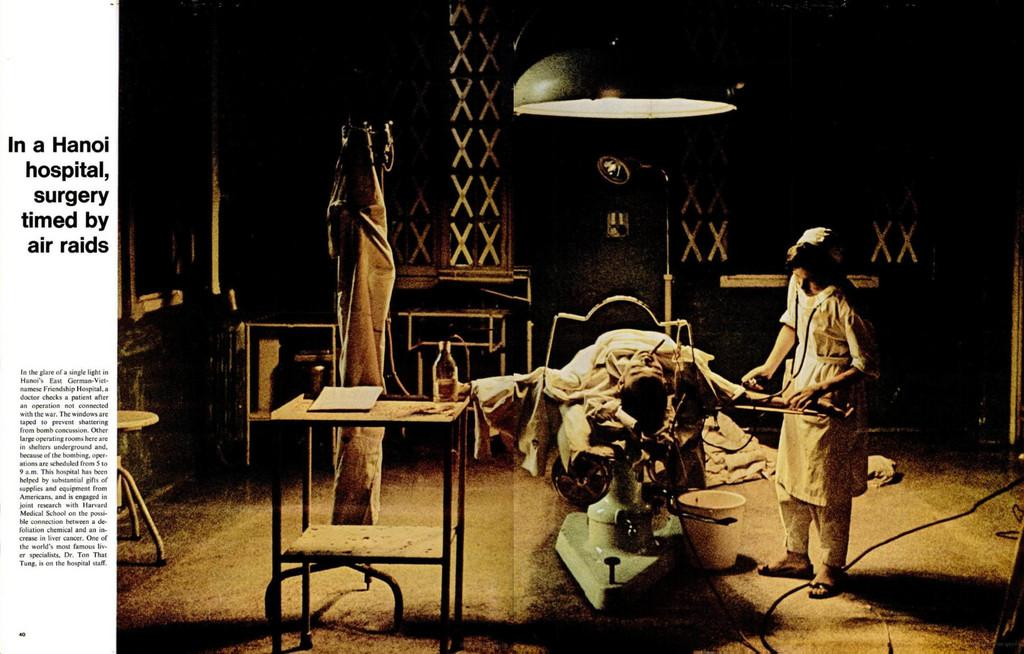What is happening on the right side of the image? There is a person on the right side of the image who is giving treatment to another person. What is the person in the middle wearing? The person in the middle is wearing a white dress. What can be seen at the top of the image? There is light visible at the top of the image. What type of toy is the person on the left side of the image playing with? There is no person on the left side of the image, and no toys are present in the image. What is the relation between the person giving treatment and the person receiving treatment? The provided facts do not give information about the relationship between the two people in the image. 